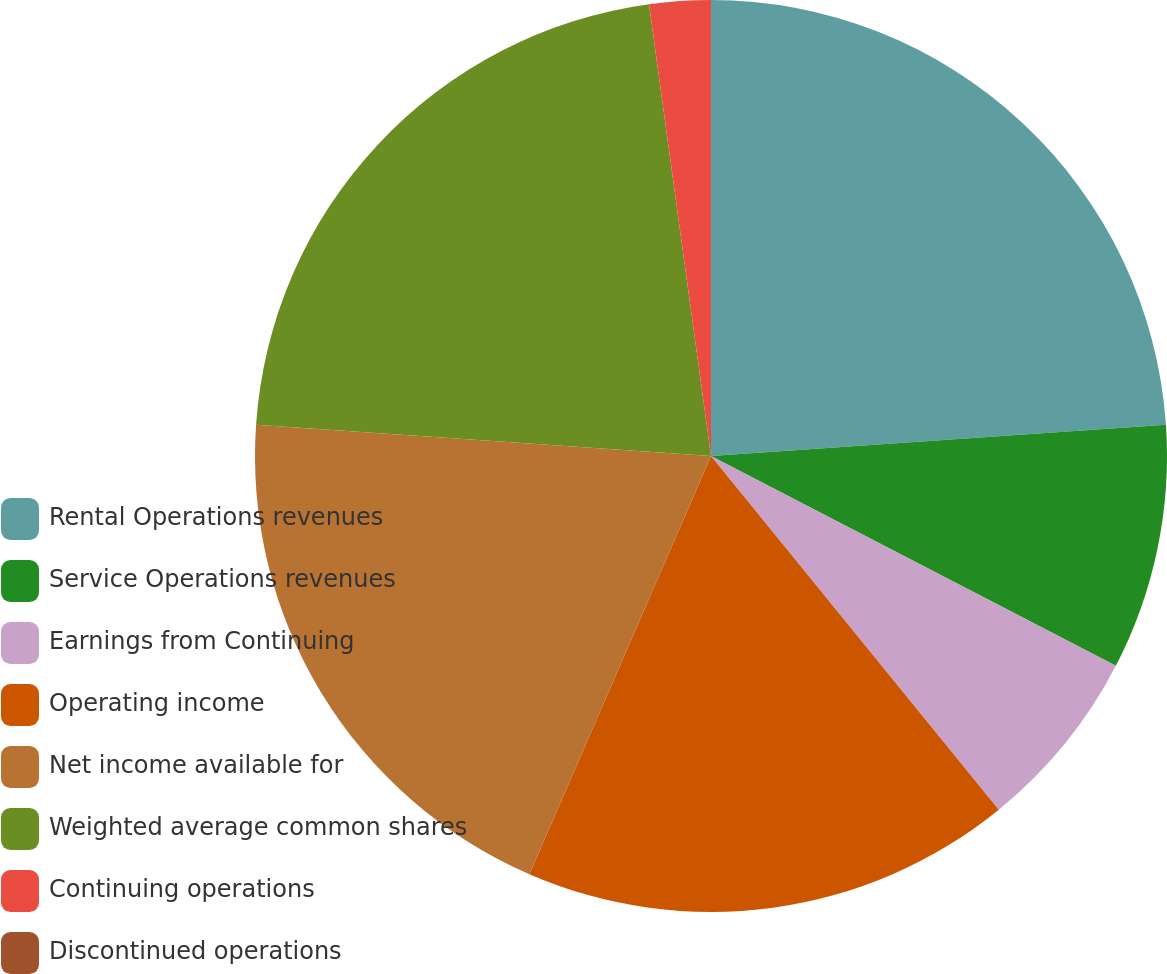Convert chart. <chart><loc_0><loc_0><loc_500><loc_500><pie_chart><fcel>Rental Operations revenues<fcel>Service Operations revenues<fcel>Earnings from Continuing<fcel>Operating income<fcel>Net income available for<fcel>Weighted average common shares<fcel>Continuing operations<fcel>Discontinued operations<nl><fcel>23.91%<fcel>8.7%<fcel>6.52%<fcel>17.39%<fcel>19.57%<fcel>21.74%<fcel>2.17%<fcel>0.0%<nl></chart> 